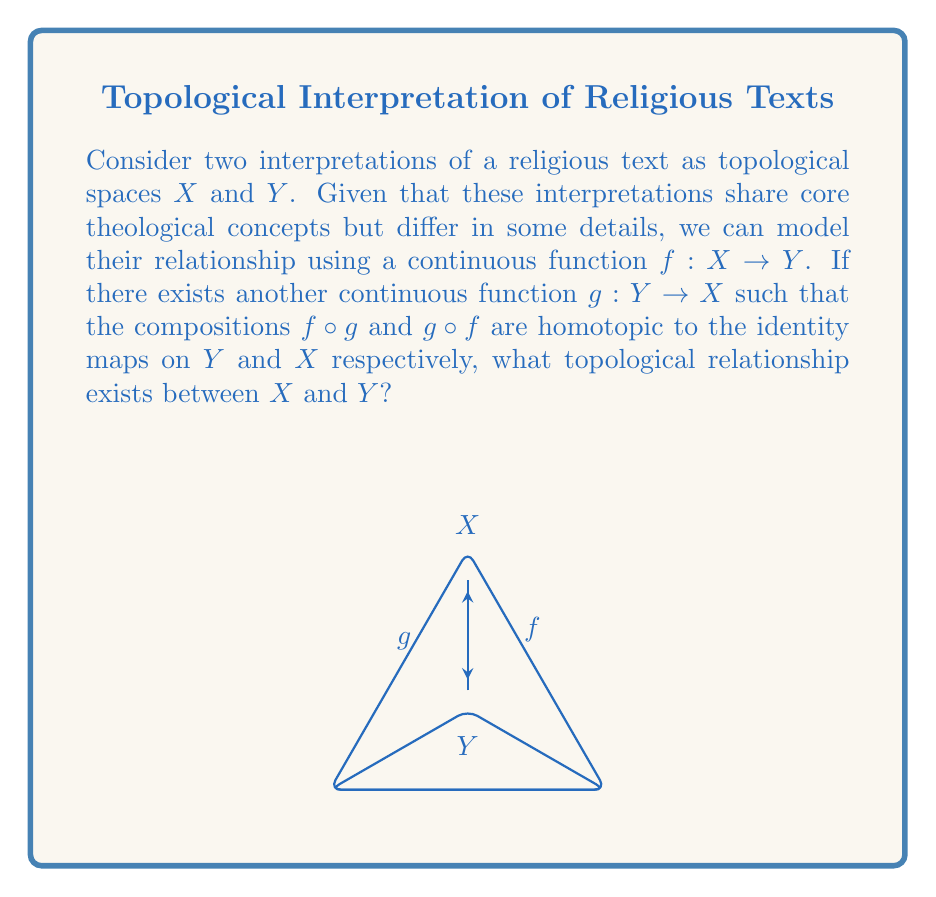Show me your answer to this math problem. To solve this problem, let's break it down step-by-step:

1) We are given two topological spaces $X$ and $Y$, representing different interpretations of a religious text.

2) We have a continuous function $f: X \rightarrow Y$ and another continuous function $g: Y \rightarrow X$.

3) We're told that the compositions $f \circ g$ and $g \circ f$ are homotopic to the identity maps on $Y$ and $X$ respectively. This means:

   $$f \circ g \simeq id_Y$$
   $$g \circ f \simeq id_X$$

   where $\simeq$ denotes homotopy equivalence.

4) In topology, when two spaces $X$ and $Y$ have continuous functions $f: X \rightarrow Y$ and $g: Y \rightarrow X$ such that $f \circ g \simeq id_Y$ and $g \circ f \simeq id_X$, we say that $X$ and $Y$ are homotopy equivalent.

5) Homotopy equivalence is a fundamental concept in algebraic topology. It suggests that while $X$ and $Y$ may not be homeomorphic (topologically identical), they share the same essential topological features.

6) In the context of religious text interpretations, this suggests that while the two interpretations may differ in some details (represented by their different topological structures), they share the same fundamental theological concepts (represented by their homotopy equivalence).

Therefore, the topological relationship that exists between $X$ and $Y$ is homotopy equivalence.
Answer: Homotopy equivalence 